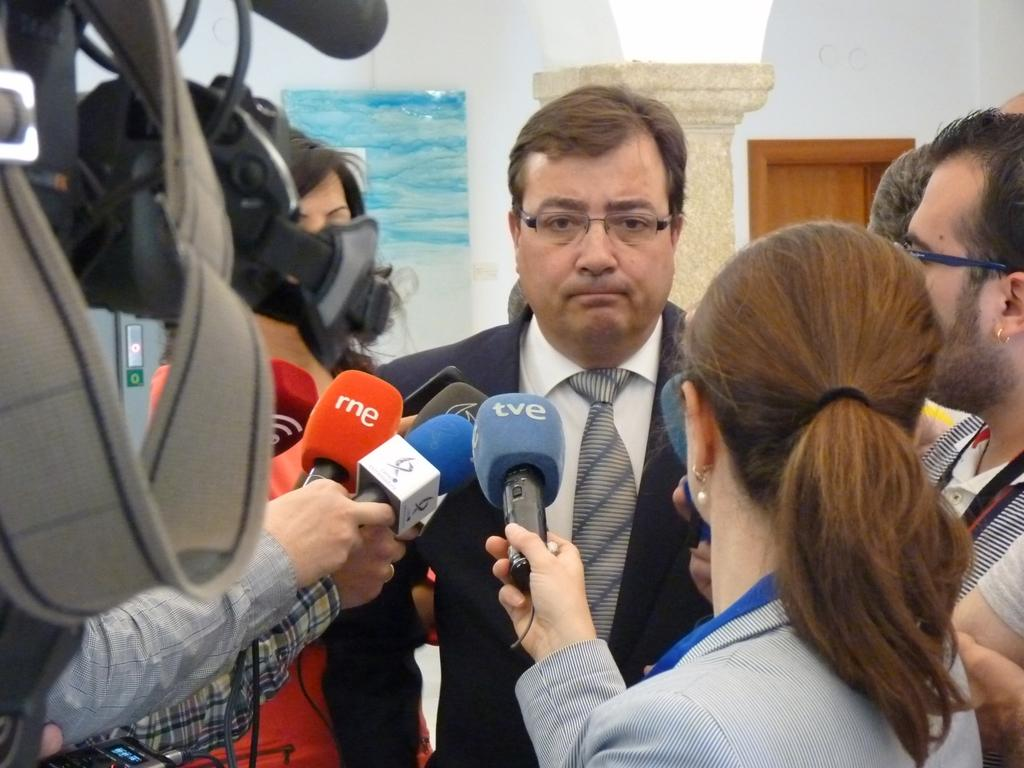Who is the main subject in the middle of the image? There is a man in the middle of the image. What are the people around the man doing? The people around the man are holding microphones. What can be seen on the left side of the image? There is a camera on the left side of the image. What type of garden can be seen in the background of the image? There is no garden visible in the image. 